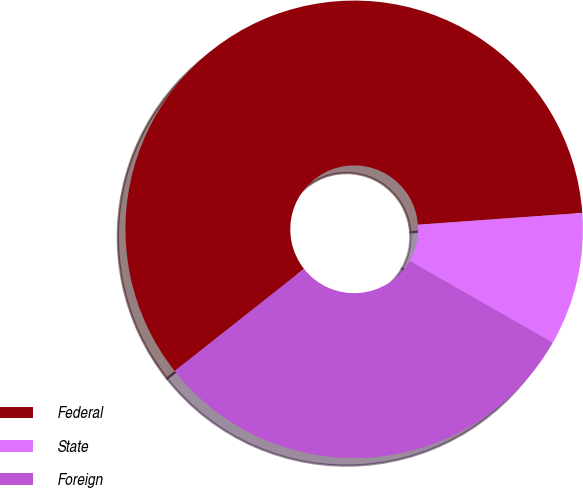Convert chart. <chart><loc_0><loc_0><loc_500><loc_500><pie_chart><fcel>Federal<fcel>State<fcel>Foreign<nl><fcel>59.5%<fcel>9.4%<fcel>31.11%<nl></chart> 